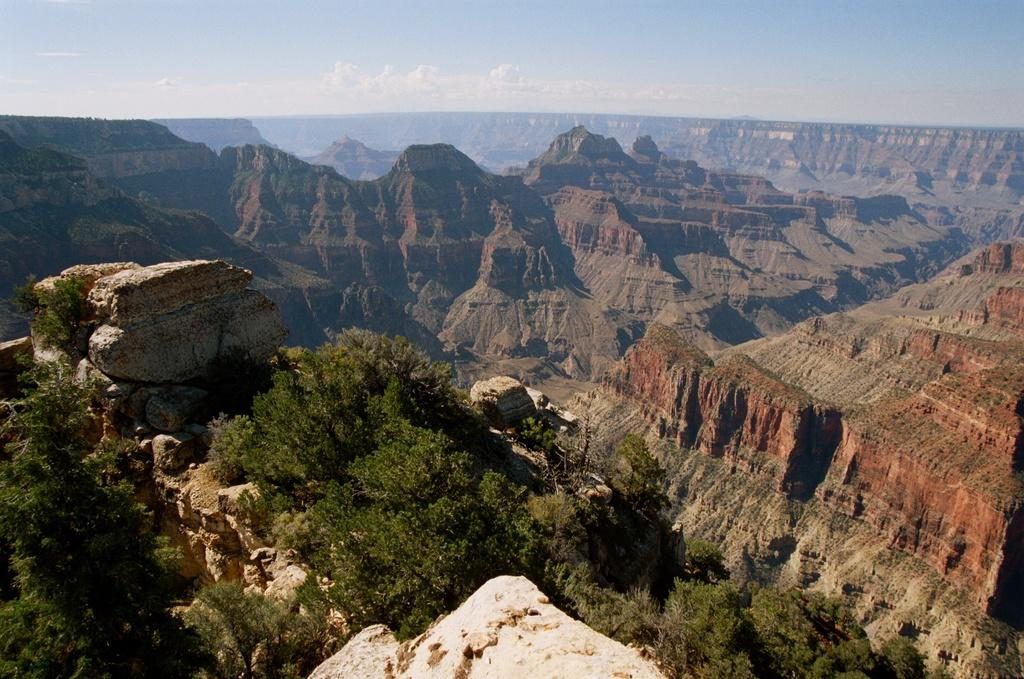What type of natural landscape is depicted in the image? The image features mountains. What other elements can be seen in the image? There are rocks, trees, and clouds visible in the image. What type of letter is being delivered by the cabbage in the image? There is no letter or cabbage present in the image. What scientific theory can be observed in the image? There is no scientific theory depicted in the image; it features mountains, rocks, trees, and clouds. 